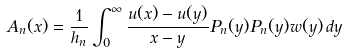<formula> <loc_0><loc_0><loc_500><loc_500>A _ { n } ( x ) = \frac { 1 } { h _ { n } } \int _ { 0 } ^ { \infty } \frac { u ( x ) - u ( y ) } { x - y } P _ { n } ( y ) P _ { n } ( y ) w ( y ) \, d y</formula> 